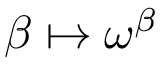Convert formula to latex. <formula><loc_0><loc_0><loc_500><loc_500>\beta \mapsto \omega ^ { \beta }</formula> 